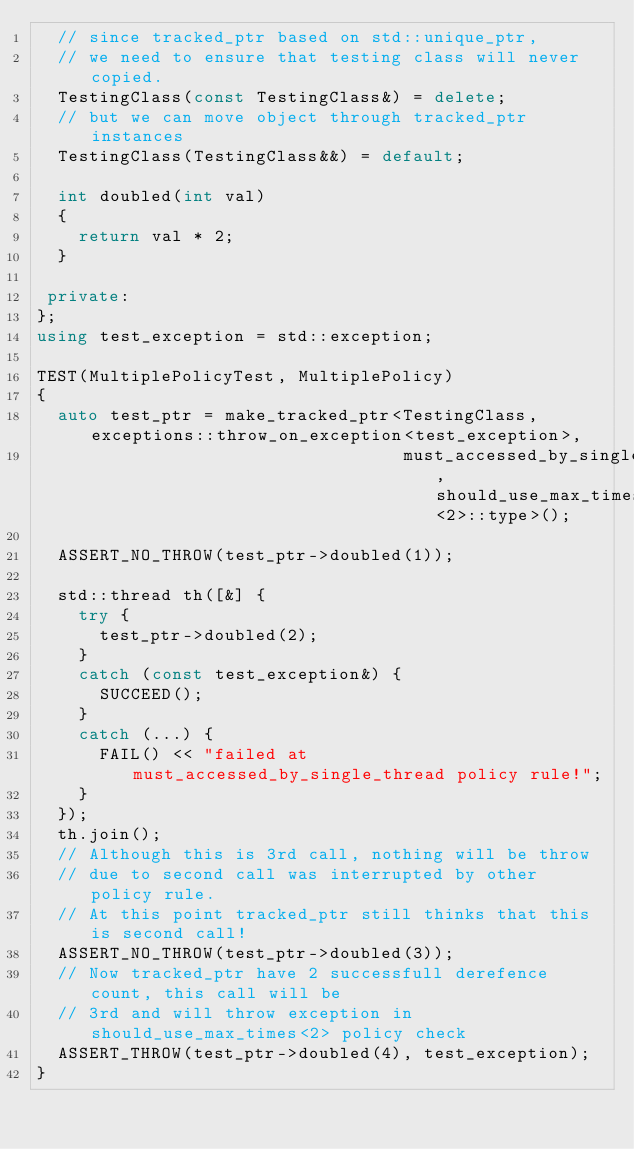Convert code to text. <code><loc_0><loc_0><loc_500><loc_500><_C++_>  // since tracked_ptr based on std::unique_ptr,
  // we need to ensure that testing class will never copied.
  TestingClass(const TestingClass&) = delete;
  // but we can move object through tracked_ptr instances
  TestingClass(TestingClass&&) = default;

  int doubled(int val)
  {
    return val * 2;
  }

 private:
};
using test_exception = std::exception;

TEST(MultiplePolicyTest, MultiplePolicy)
{
  auto test_ptr = make_tracked_ptr<TestingClass, exceptions::throw_on_exception<test_exception>,
                                   must_accessed_by_single_thread, should_use_max_times<2>::type>();
  
  ASSERT_NO_THROW(test_ptr->doubled(1));

  std::thread th([&] {
    try {
      test_ptr->doubled(2);
    }
    catch (const test_exception&) {
      SUCCEED();
    }
    catch (...) {
      FAIL() << "failed at must_accessed_by_single_thread policy rule!";
    }
  });
  th.join();
  // Although this is 3rd call, nothing will be throw
  // due to second call was interrupted by other policy rule. 
  // At this point tracked_ptr still thinks that this is second call!
  ASSERT_NO_THROW(test_ptr->doubled(3));
  // Now tracked_ptr have 2 successfull derefence count, this call will be
  // 3rd and will throw exception in should_use_max_times<2> policy check
  ASSERT_THROW(test_ptr->doubled(4), test_exception);
}
</code> 